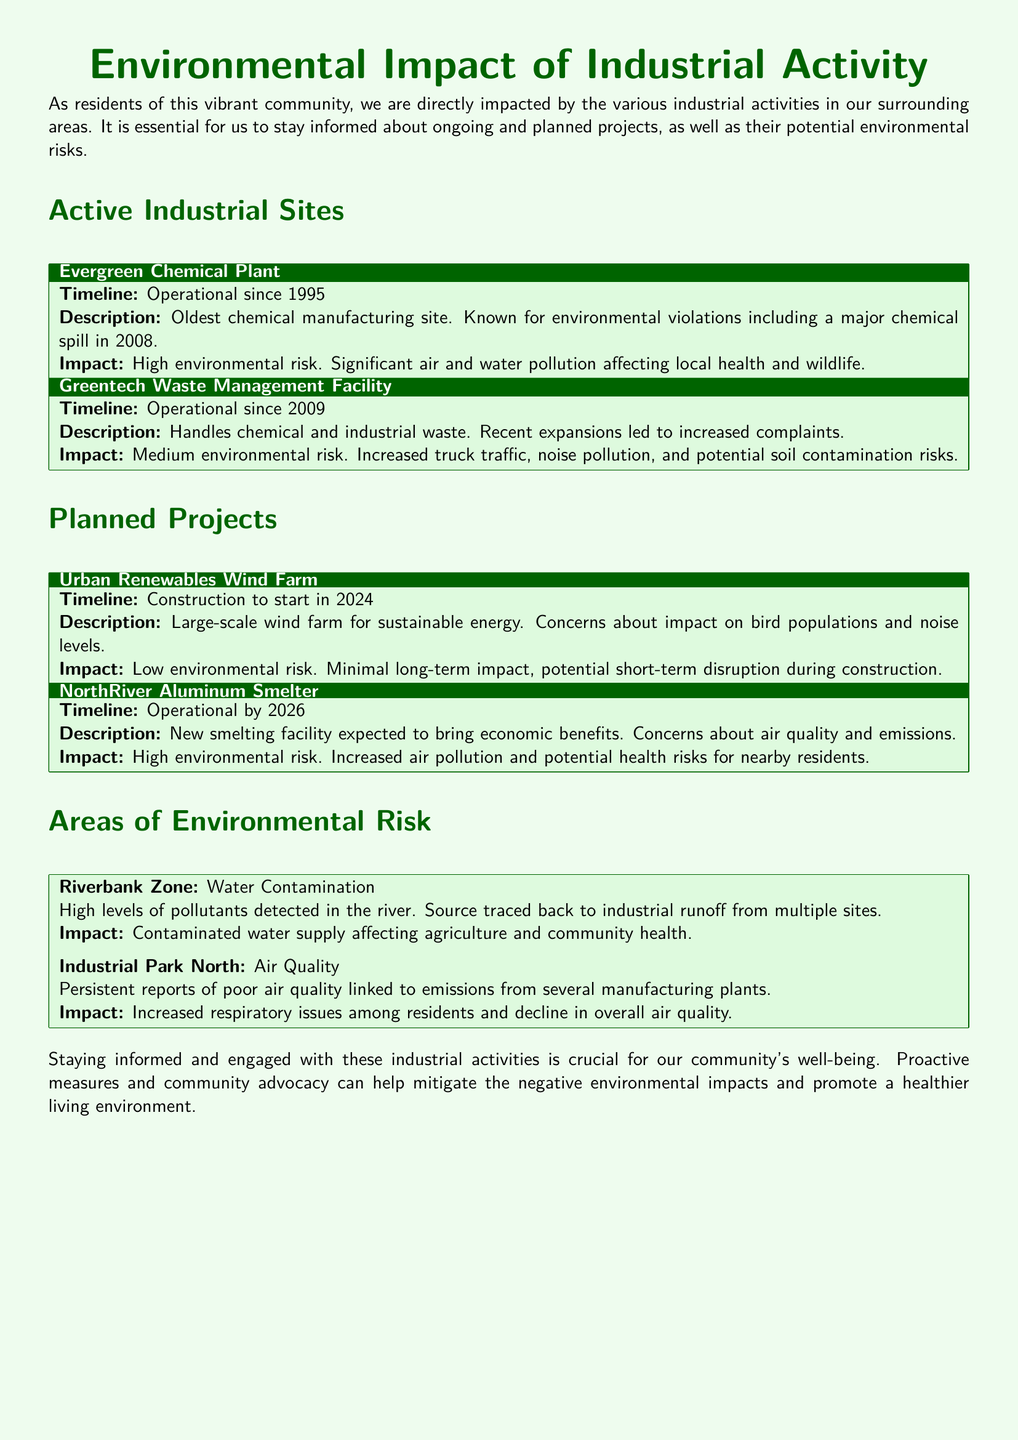What is the name of the oldest chemical manufacturing site? The document lists "Evergreen Chemical Plant" as the oldest chemical manufacturing site.
Answer: Evergreen Chemical Plant When did the NorthRiver Aluminum Smelter project become operational? According to the timeline in the document, the NorthRiver Aluminum Smelter is expected to be operational by 2026.
Answer: 2026 What is the main environmental risk associated with the Greentech Waste Management Facility? The document indicates that the facility has a medium environmental risk, particularly due to increased truck traffic, noise pollution, and potential soil contamination risks.
Answer: Medium environmental risk What construction is scheduled to start in 2024? The document states the "Urban Renewables Wind Farm" construction is planned to start in 2024.
Answer: Urban Renewables Wind Farm What area is affected by high levels of water contamination? The document states that the "Riverbank Zone" is affected by high levels of water contamination.
Answer: Riverbank Zone Which planned project is expected to have low environmental risk? According to the document, the "Urban Renewables Wind Farm" is expected to have low environmental risk.
Answer: Urban Renewables Wind Farm What health impact is reported in the Industrial Park North area? The document reports that there are increased respiratory issues among residents linked to air quality.
Answer: Increased respiratory issues What significant event occurred at the Evergreen Chemical Plant in 2008? The document mentions that there was a major chemical spill at the Evergreen Chemical Plant in 2008.
Answer: Major chemical spill What is the anticipated impact of the NorthRiver Aluminum Smelter on air quality? The document outlines that the facility is expected to increase air pollution and present potential health risks for nearby residents.
Answer: Increased air pollution 